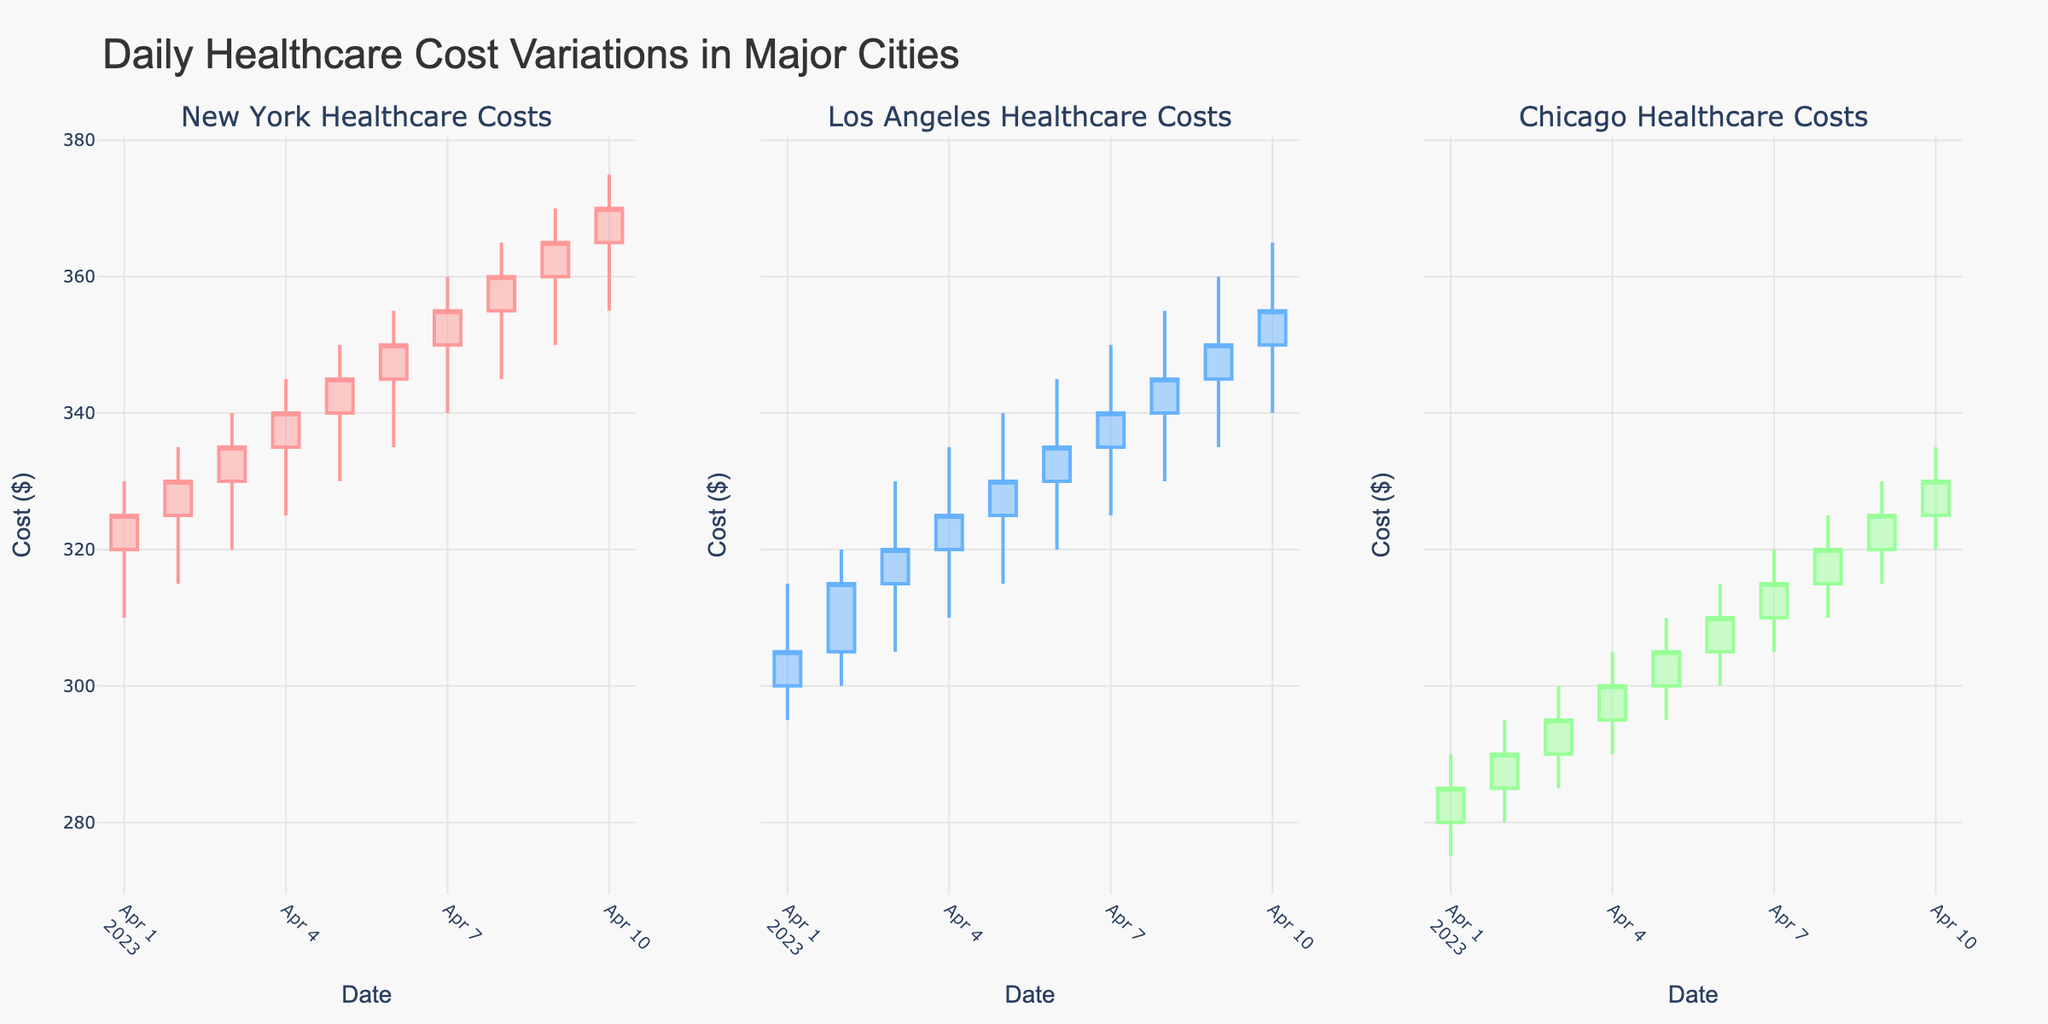What is the title of the figure? The title of the figure is usually located at the top of the plot. In this case, it reads "Daily Healthcare Cost Variations in Major Cities".
Answer: Daily Healthcare Cost Variations in Major Cities How many cities' data are represented in the figure? The figure is a subplot with titles indicating the cities. The titles mention three cities: New York, Los Angeles, and Chicago.
Answer: Three Which city had the highest closing cost on 2023-04-10? To find the answer, look at the candlestick for 2023-04-10 in each city's subplot and compare the closing prices. New York had the highest closing cost of $370.
Answer: New York What was the closing cost for Los Angeles on 2023-04-04? Locate the candlestick for 2023-04-04 in Los Angeles' subplot. The closing cost for that date is given by the top of the candlestick body, which is $325.
Answer: $325 Which day saw the greatest price range (difference between high and low) for Chicago? Examine the height difference between the top and bottom of each candlestick (high and low prices) for Chicago. The greatest difference is on 2023-04-10 with a high of $335 and a low of $320, making the range $15.
Answer: 2023-04-10 How do the closing costs for New York on 2023-04-05 and 2023-04-07 compare? Look at the closing prices for New York on those dates. For 2023-04-05, it is $345, and for 2023-04-07, it is $355. So, the closing cost increased by $10.
Answer: The cost increased by $10 On which day did Los Angeles have the smallest increase from opening to closing cost? Compare the difference between the opening and closing costs for each day in Los Angeles' subplot. The smallest increase occurred on 2023-04-06, where the closing cost ($335) was $5 higher than the opening cost ($330).
Answer: 2023-04-06 Between which days did New York experience the highest increase in closing costs? Compare the closing costs for consecutive days in New York's subplot. The biggest increase is from 2023-04-09 to 2023-04-10, where the closing cost increased from $365 to $370, an increase of $5.
Answer: 2023-04-09 and 2023-04-10 Was there any day when Chicago's closing cost was lower than the opening cost? Check if there are any candlesticks in Chicago's subplot that are colored gray, indicating the closing cost was less than the opening cost. There are none, as Chicago's candlesticks are colored green for increasing costs.
Answer: No Which city had a higher opening cost on 2023-04-02, New York or Los Angeles? Compare the opening costs for New York and Los Angeles on 2023-04-02. New York had an opening cost of $325, whereas Los Angeles opened at $305. Therefore, New York's opening cost was higher.
Answer: New York 